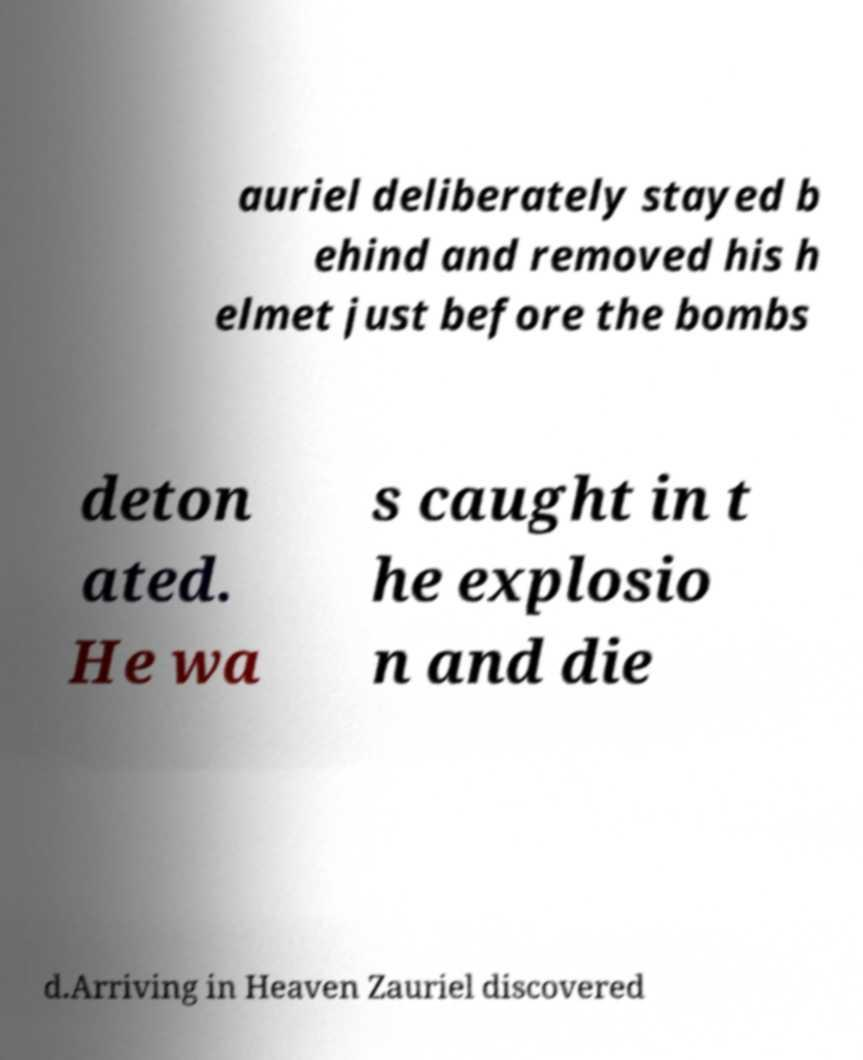What messages or text are displayed in this image? I need them in a readable, typed format. auriel deliberately stayed b ehind and removed his h elmet just before the bombs deton ated. He wa s caught in t he explosio n and die d.Arriving in Heaven Zauriel discovered 